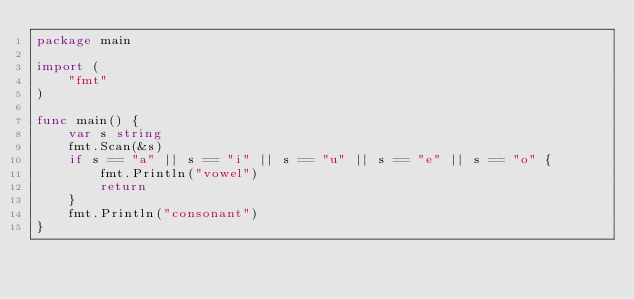Convert code to text. <code><loc_0><loc_0><loc_500><loc_500><_Go_>package main

import (
	"fmt"
)

func main() {
	var s string
	fmt.Scan(&s)
	if s == "a" || s == "i" || s == "u" || s == "e" || s == "o" {
		fmt.Println("vowel")
		return
	}
	fmt.Println("consonant")
}
</code> 